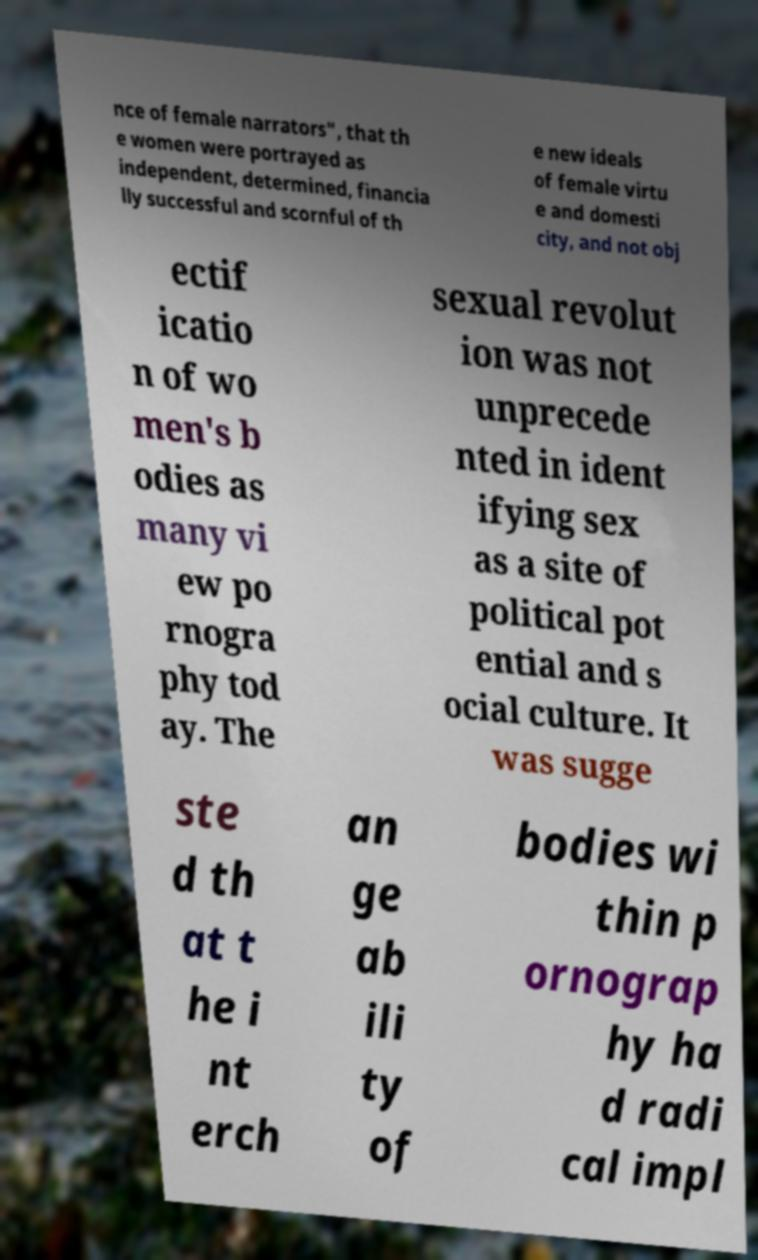Could you extract and type out the text from this image? nce of female narrators", that th e women were portrayed as independent, determined, financia lly successful and scornful of th e new ideals of female virtu e and domesti city, and not obj ectif icatio n of wo men's b odies as many vi ew po rnogra phy tod ay. The sexual revolut ion was not unprecede nted in ident ifying sex as a site of political pot ential and s ocial culture. It was sugge ste d th at t he i nt erch an ge ab ili ty of bodies wi thin p ornograp hy ha d radi cal impl 